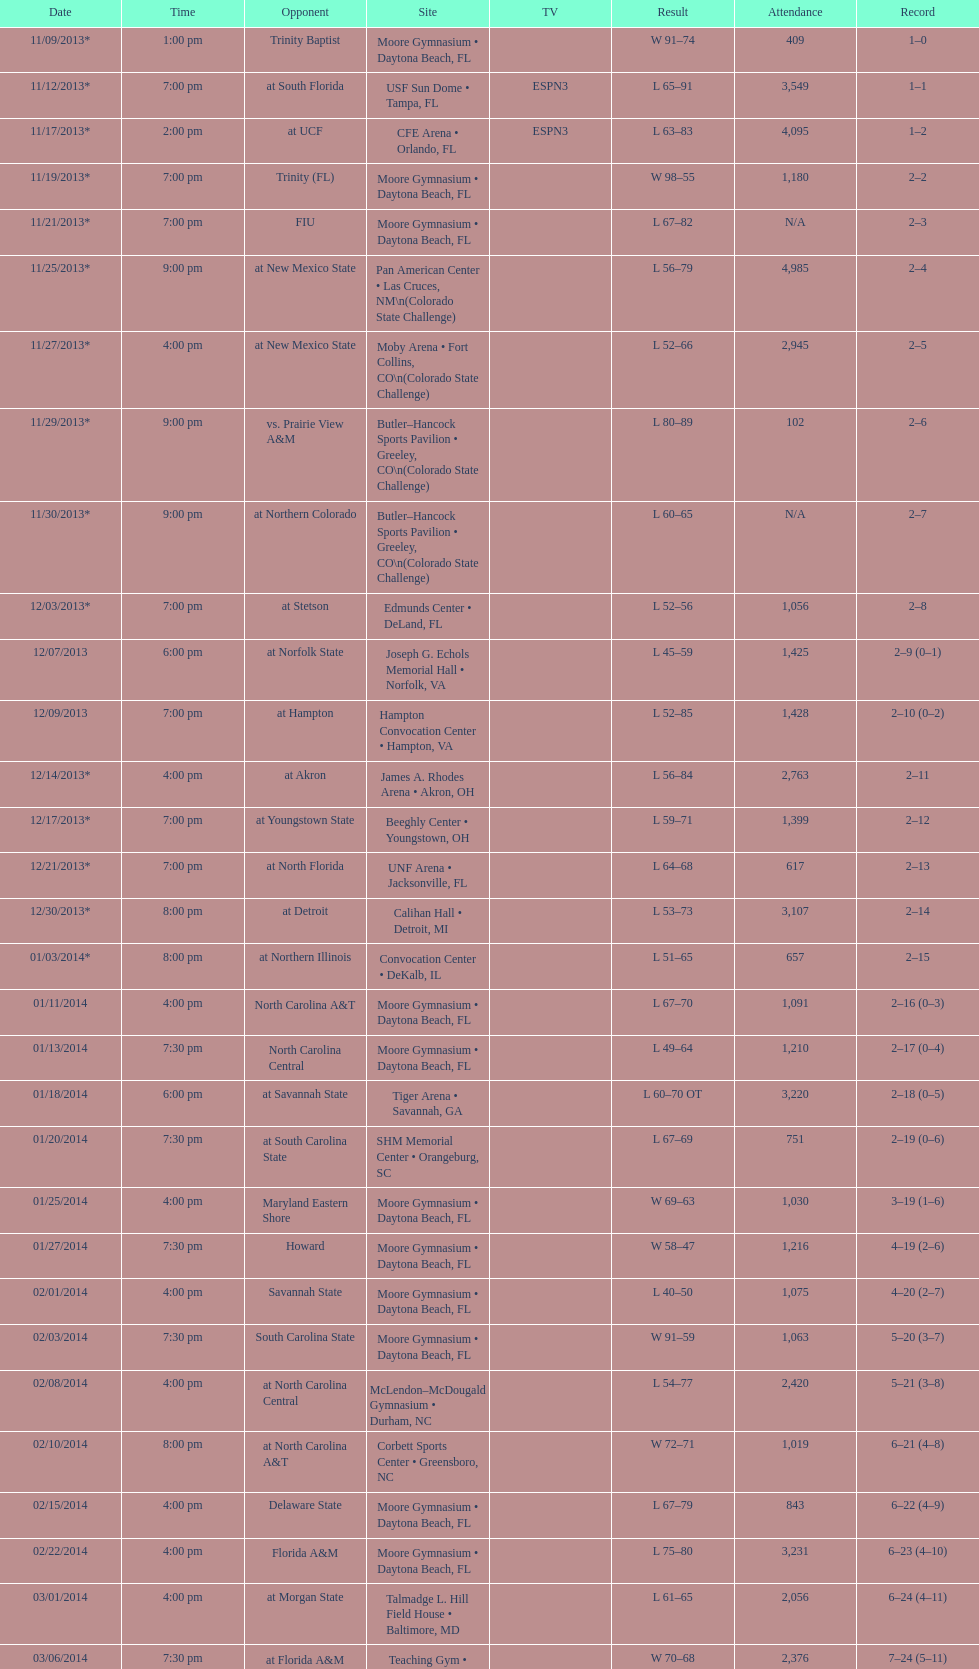Could you parse the entire table as a dict? {'header': ['Date', 'Time', 'Opponent', 'Site', 'TV', 'Result', 'Attendance', 'Record'], 'rows': [['11/09/2013*', '1:00 pm', 'Trinity Baptist', 'Moore Gymnasium • Daytona Beach, FL', '', 'W\xa091–74', '409', '1–0'], ['11/12/2013*', '7:00 pm', 'at\xa0South Florida', 'USF Sun Dome • Tampa, FL', 'ESPN3', 'L\xa065–91', '3,549', '1–1'], ['11/17/2013*', '2:00 pm', 'at\xa0UCF', 'CFE Arena • Orlando, FL', 'ESPN3', 'L\xa063–83', '4,095', '1–2'], ['11/19/2013*', '7:00 pm', 'Trinity (FL)', 'Moore Gymnasium • Daytona Beach, FL', '', 'W\xa098–55', '1,180', '2–2'], ['11/21/2013*', '7:00 pm', 'FIU', 'Moore Gymnasium • Daytona Beach, FL', '', 'L\xa067–82', 'N/A', '2–3'], ['11/25/2013*', '9:00 pm', 'at\xa0New Mexico State', 'Pan American Center • Las Cruces, NM\\n(Colorado State Challenge)', '', 'L\xa056–79', '4,985', '2–4'], ['11/27/2013*', '4:00 pm', 'at\xa0New Mexico State', 'Moby Arena • Fort Collins, CO\\n(Colorado State Challenge)', '', 'L\xa052–66', '2,945', '2–5'], ['11/29/2013*', '9:00 pm', 'vs.\xa0Prairie View A&M', 'Butler–Hancock Sports Pavilion • Greeley, CO\\n(Colorado State Challenge)', '', 'L\xa080–89', '102', '2–6'], ['11/30/2013*', '9:00 pm', 'at\xa0Northern Colorado', 'Butler–Hancock Sports Pavilion • Greeley, CO\\n(Colorado State Challenge)', '', 'L\xa060–65', 'N/A', '2–7'], ['12/03/2013*', '7:00 pm', 'at\xa0Stetson', 'Edmunds Center • DeLand, FL', '', 'L\xa052–56', '1,056', '2–8'], ['12/07/2013', '6:00 pm', 'at\xa0Norfolk State', 'Joseph G. Echols Memorial Hall • Norfolk, VA', '', 'L\xa045–59', '1,425', '2–9 (0–1)'], ['12/09/2013', '7:00 pm', 'at\xa0Hampton', 'Hampton Convocation Center • Hampton, VA', '', 'L\xa052–85', '1,428', '2–10 (0–2)'], ['12/14/2013*', '4:00 pm', 'at\xa0Akron', 'James A. Rhodes Arena • Akron, OH', '', 'L\xa056–84', '2,763', '2–11'], ['12/17/2013*', '7:00 pm', 'at\xa0Youngstown State', 'Beeghly Center • Youngstown, OH', '', 'L\xa059–71', '1,399', '2–12'], ['12/21/2013*', '7:00 pm', 'at\xa0North Florida', 'UNF Arena • Jacksonville, FL', '', 'L\xa064–68', '617', '2–13'], ['12/30/2013*', '8:00 pm', 'at\xa0Detroit', 'Calihan Hall • Detroit, MI', '', 'L\xa053–73', '3,107', '2–14'], ['01/03/2014*', '8:00 pm', 'at\xa0Northern Illinois', 'Convocation Center • DeKalb, IL', '', 'L\xa051–65', '657', '2–15'], ['01/11/2014', '4:00 pm', 'North Carolina A&T', 'Moore Gymnasium • Daytona Beach, FL', '', 'L\xa067–70', '1,091', '2–16 (0–3)'], ['01/13/2014', '7:30 pm', 'North Carolina Central', 'Moore Gymnasium • Daytona Beach, FL', '', 'L\xa049–64', '1,210', '2–17 (0–4)'], ['01/18/2014', '6:00 pm', 'at\xa0Savannah State', 'Tiger Arena • Savannah, GA', '', 'L\xa060–70\xa0OT', '3,220', '2–18 (0–5)'], ['01/20/2014', '7:30 pm', 'at\xa0South Carolina State', 'SHM Memorial Center • Orangeburg, SC', '', 'L\xa067–69', '751', '2–19 (0–6)'], ['01/25/2014', '4:00 pm', 'Maryland Eastern Shore', 'Moore Gymnasium • Daytona Beach, FL', '', 'W\xa069–63', '1,030', '3–19 (1–6)'], ['01/27/2014', '7:30 pm', 'Howard', 'Moore Gymnasium • Daytona Beach, FL', '', 'W\xa058–47', '1,216', '4–19 (2–6)'], ['02/01/2014', '4:00 pm', 'Savannah State', 'Moore Gymnasium • Daytona Beach, FL', '', 'L\xa040–50', '1,075', '4–20 (2–7)'], ['02/03/2014', '7:30 pm', 'South Carolina State', 'Moore Gymnasium • Daytona Beach, FL', '', 'W\xa091–59', '1,063', '5–20 (3–7)'], ['02/08/2014', '4:00 pm', 'at\xa0North Carolina Central', 'McLendon–McDougald Gymnasium • Durham, NC', '', 'L\xa054–77', '2,420', '5–21 (3–8)'], ['02/10/2014', '8:00 pm', 'at\xa0North Carolina A&T', 'Corbett Sports Center • Greensboro, NC', '', 'W\xa072–71', '1,019', '6–21 (4–8)'], ['02/15/2014', '4:00 pm', 'Delaware State', 'Moore Gymnasium • Daytona Beach, FL', '', 'L\xa067–79', '843', '6–22 (4–9)'], ['02/22/2014', '4:00 pm', 'Florida A&M', 'Moore Gymnasium • Daytona Beach, FL', '', 'L\xa075–80', '3,231', '6–23 (4–10)'], ['03/01/2014', '4:00 pm', 'at\xa0Morgan State', 'Talmadge L. Hill Field House • Baltimore, MD', '', 'L\xa061–65', '2,056', '6–24 (4–11)'], ['03/06/2014', '7:30 pm', 'at\xa0Florida A&M', 'Teaching Gym • Tallahassee, FL', '', 'W\xa070–68', '2,376', '7–24 (5–11)'], ['03/11/2014', '6:30 pm', 'vs.\xa0Coppin State', 'Norfolk Scope • Norfolk, VA\\n(First round)', '', 'L\xa068–75', '4,658', '7–25']]} What was the difference in attendance between 11/25/2013 and 12/21/2013? 4368. 